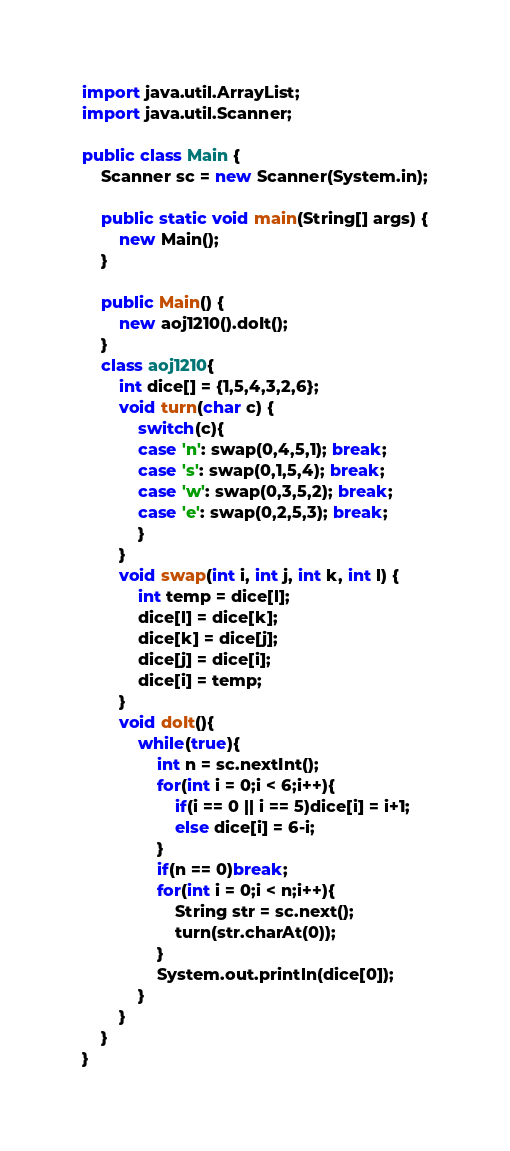<code> <loc_0><loc_0><loc_500><loc_500><_Java_>import java.util.ArrayList;
import java.util.Scanner;
 
public class Main {
    Scanner sc = new Scanner(System.in);
   
    public static void main(String[] args) {
        new Main(); 
    }
   
    public Main() {
        new aoj1210().doIt();
    }
    class aoj1210{
    	int dice[] = {1,5,4,3,2,6};
    	void turn(char c) {
			switch(c){
			case 'n': swap(0,4,5,1); break;
			case 's': swap(0,1,5,4); break;
			case 'w': swap(0,3,5,2); break;
			case 'e': swap(0,2,5,3); break;
			}
		}
		void swap(int i, int j, int k, int l) {
			int temp = dice[l];
			dice[l] = dice[k];
			dice[k] = dice[j];
			dice[j] = dice[i];
			dice[i] = temp;
		}
    	void doIt(){
    		while(true){
    			int n = sc.nextInt();
    			for(int i = 0;i < 6;i++){
    				if(i == 0 || i == 5)dice[i] = i+1;
    				else dice[i] = 6-i;
    			}
    			if(n == 0)break;
    			for(int i = 0;i < n;i++){
    				String str = sc.next();
    				turn(str.charAt(0));
    			}
    			System.out.println(dice[0]);
    		}
    	}
    }
}</code> 